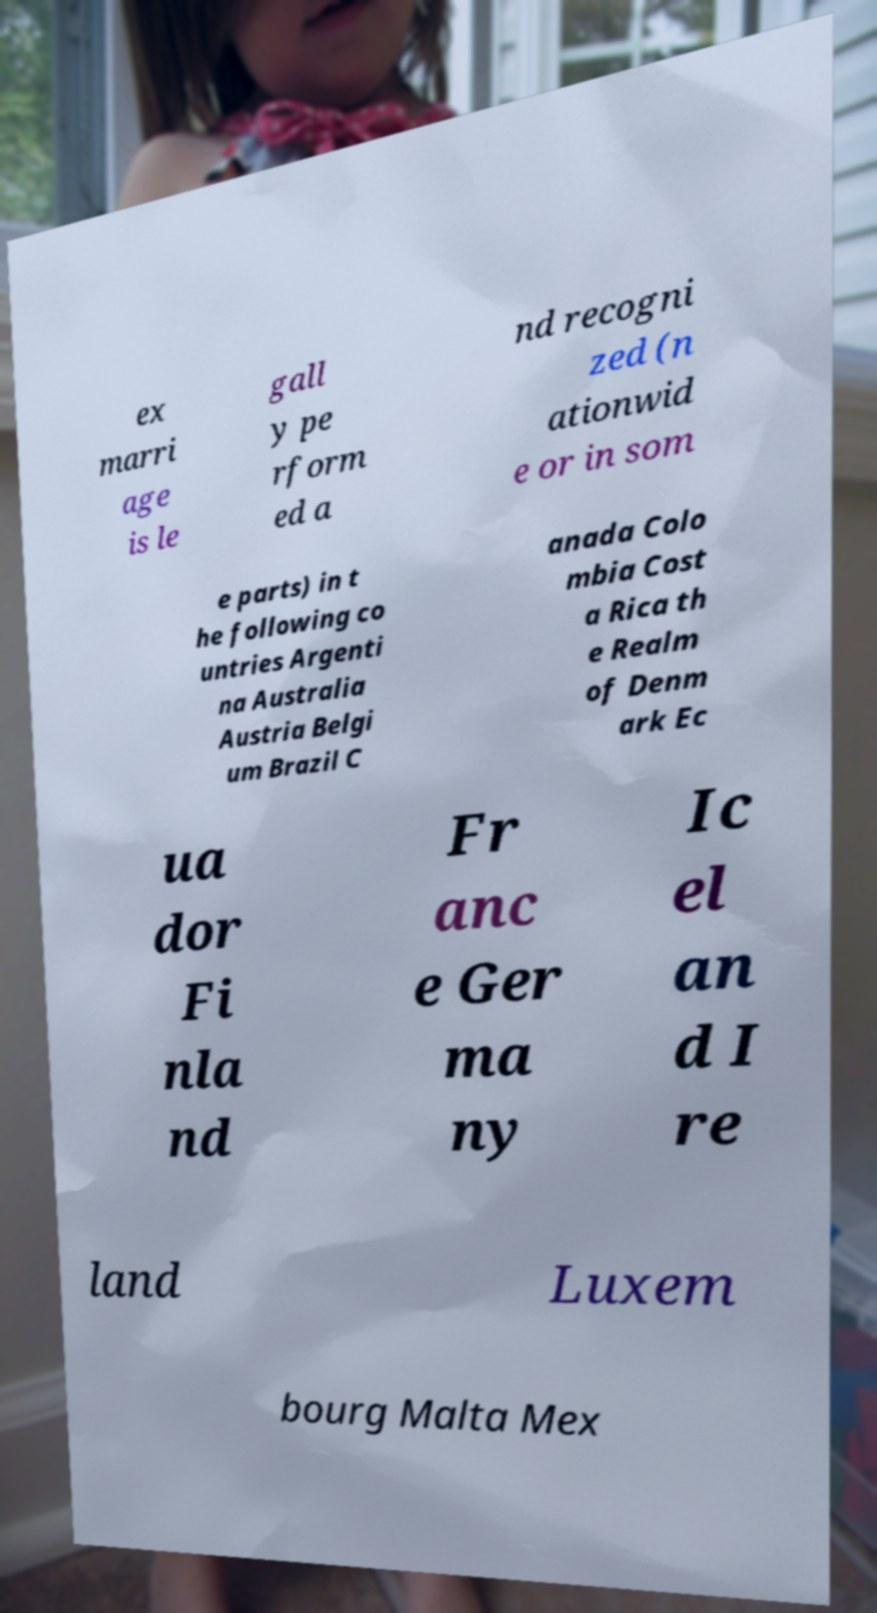For documentation purposes, I need the text within this image transcribed. Could you provide that? ex marri age is le gall y pe rform ed a nd recogni zed (n ationwid e or in som e parts) in t he following co untries Argenti na Australia Austria Belgi um Brazil C anada Colo mbia Cost a Rica th e Realm of Denm ark Ec ua dor Fi nla nd Fr anc e Ger ma ny Ic el an d I re land Luxem bourg Malta Mex 